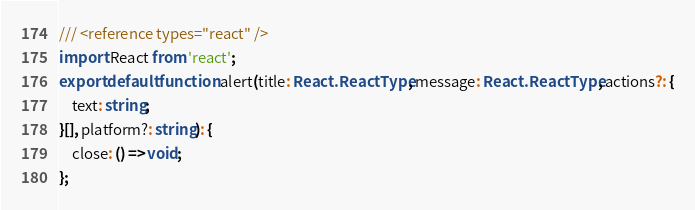<code> <loc_0><loc_0><loc_500><loc_500><_TypeScript_>/// <reference types="react" />
import React from 'react';
export default function alert(title: React.ReactType, message: React.ReactType, actions?: {
    text: string;
}[], platform?: string): {
    close: () => void;
};
</code> 